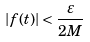<formula> <loc_0><loc_0><loc_500><loc_500>\left | f ( t ) \right | < \frac { \varepsilon } { 2 M } \text {\quad }</formula> 